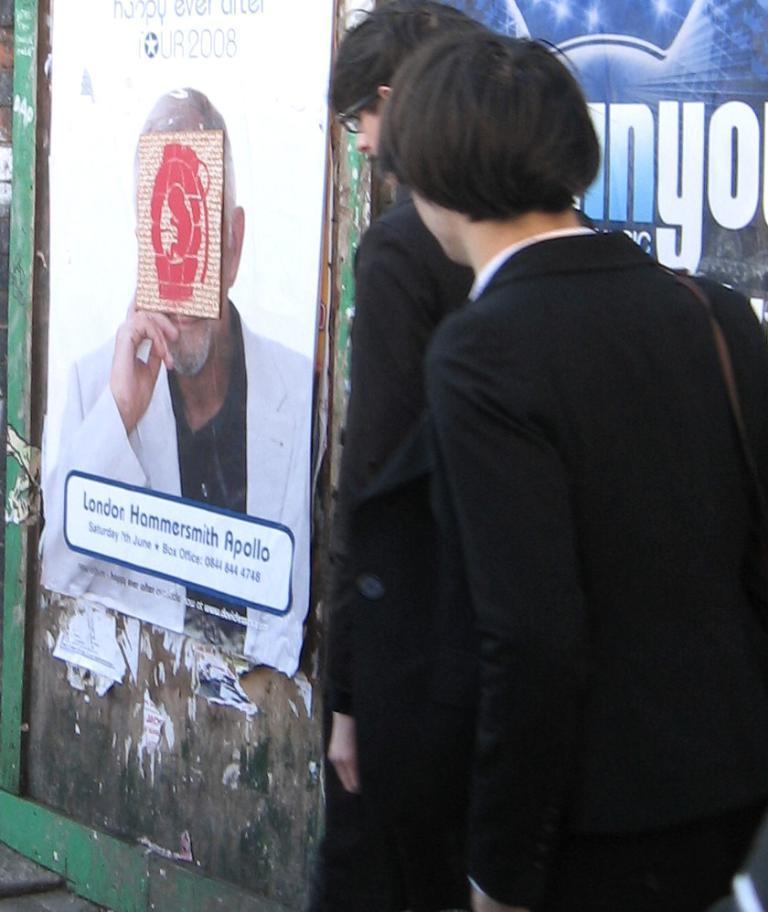Can you describe this image briefly? In the image we can see two people wearing clothes and one person is wearing spectacles. We can even see a poster stick to the wall. There is a text, wall and footpath. 